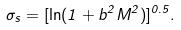<formula> <loc_0><loc_0><loc_500><loc_500>\sigma _ { s } = [ \ln ( 1 + b ^ { 2 } M ^ { 2 } ) ] ^ { 0 . 5 } .</formula> 